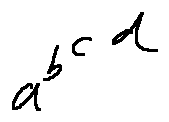<formula> <loc_0><loc_0><loc_500><loc_500>a ^ { b ^ { c ^ { d } } }</formula> 